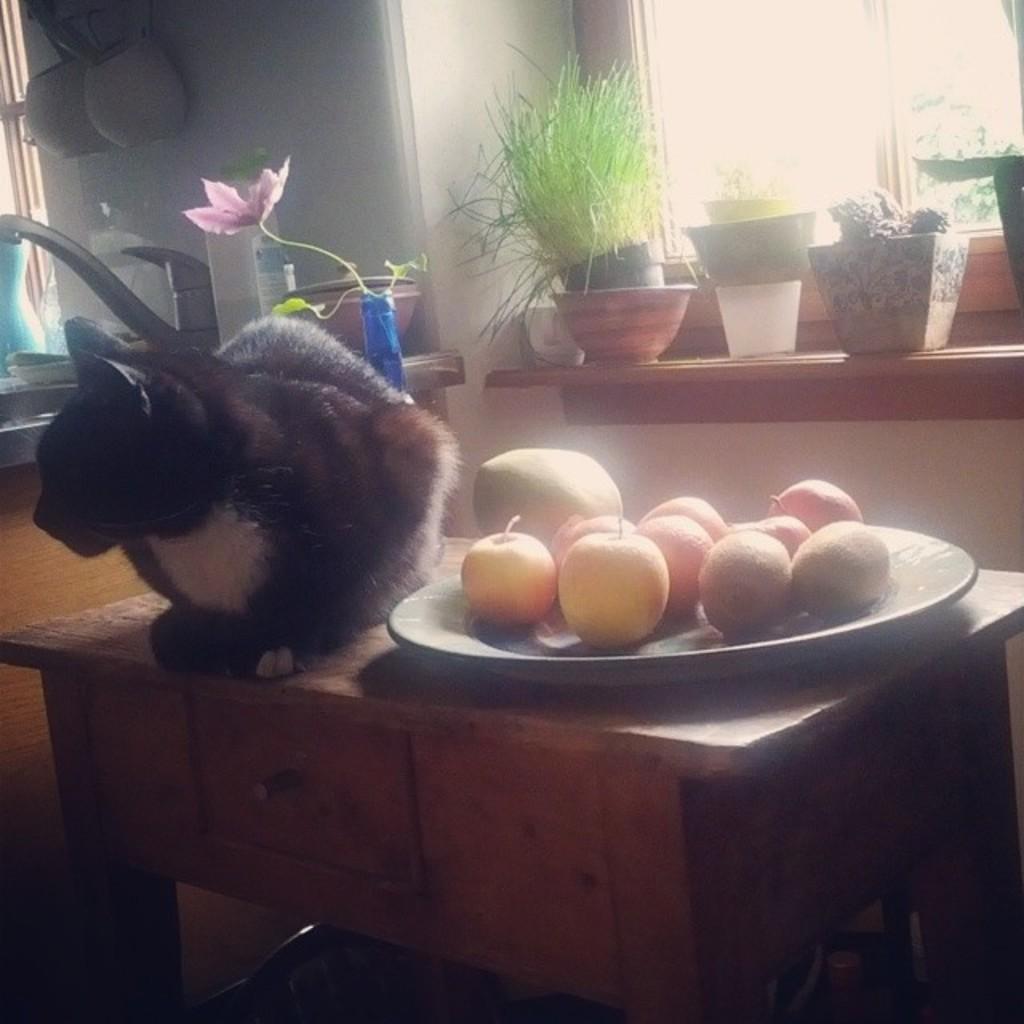Please provide a concise description of this image. In this image we can see a cat and a plate of fruits on a table. Behind the cat, we can see a wall, window and few flower pots on a rack. In the top left, we can see few objects on the wall. 